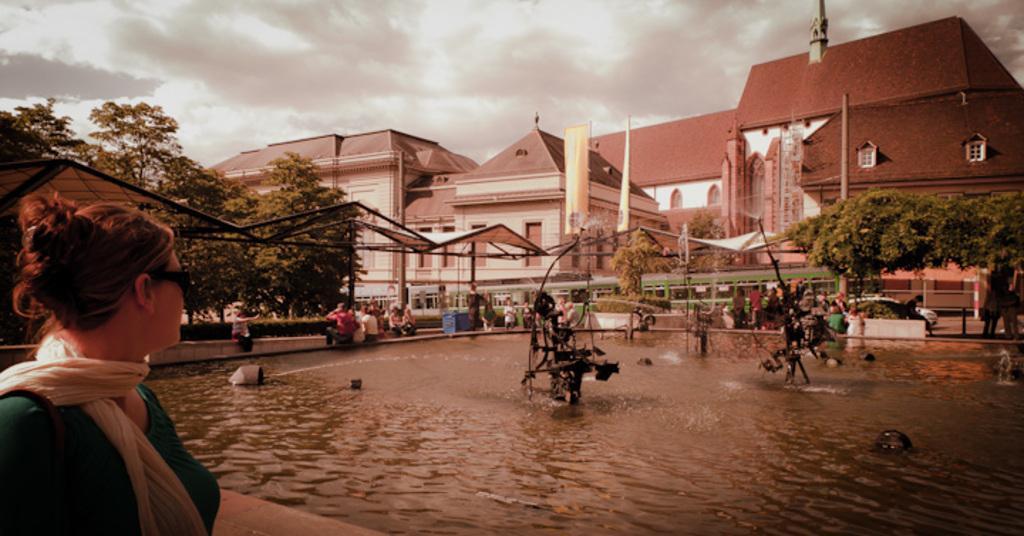How would you summarize this image in a sentence or two? In this image in the front there is a person. In the center there is water and in the water there are objects which are black in colour. In the background there are persons sitting and standing, there are trees, buildings and there are cars and the sky is cloudy. 